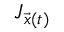<formula> <loc_0><loc_0><loc_500><loc_500>J _ { \vec { x } ( t ) }</formula> 